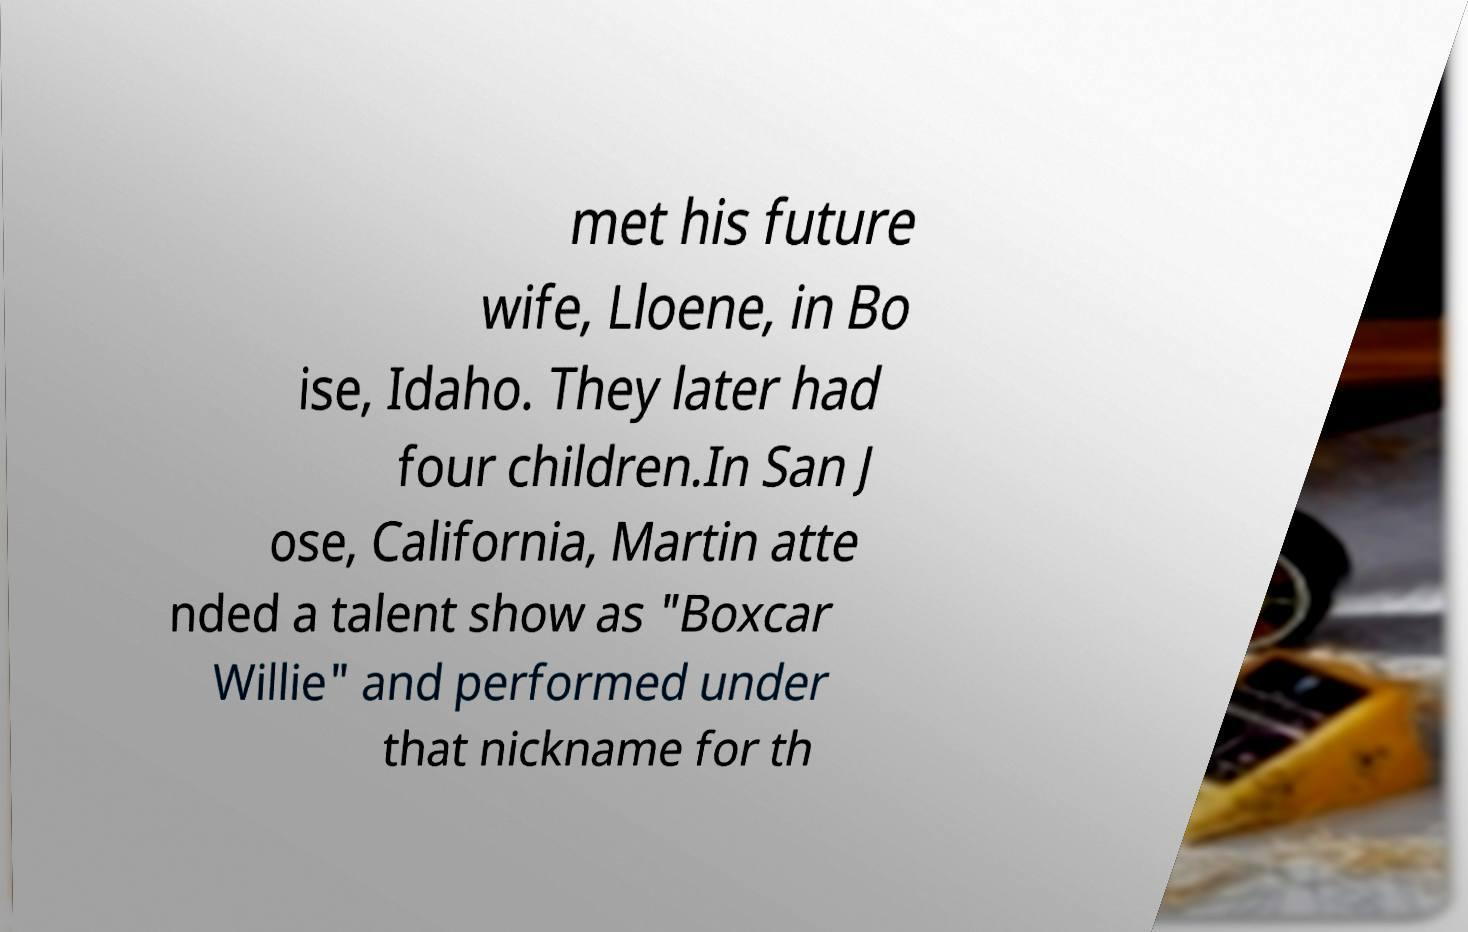For documentation purposes, I need the text within this image transcribed. Could you provide that? met his future wife, Lloene, in Bo ise, Idaho. They later had four children.In San J ose, California, Martin atte nded a talent show as "Boxcar Willie" and performed under that nickname for th 